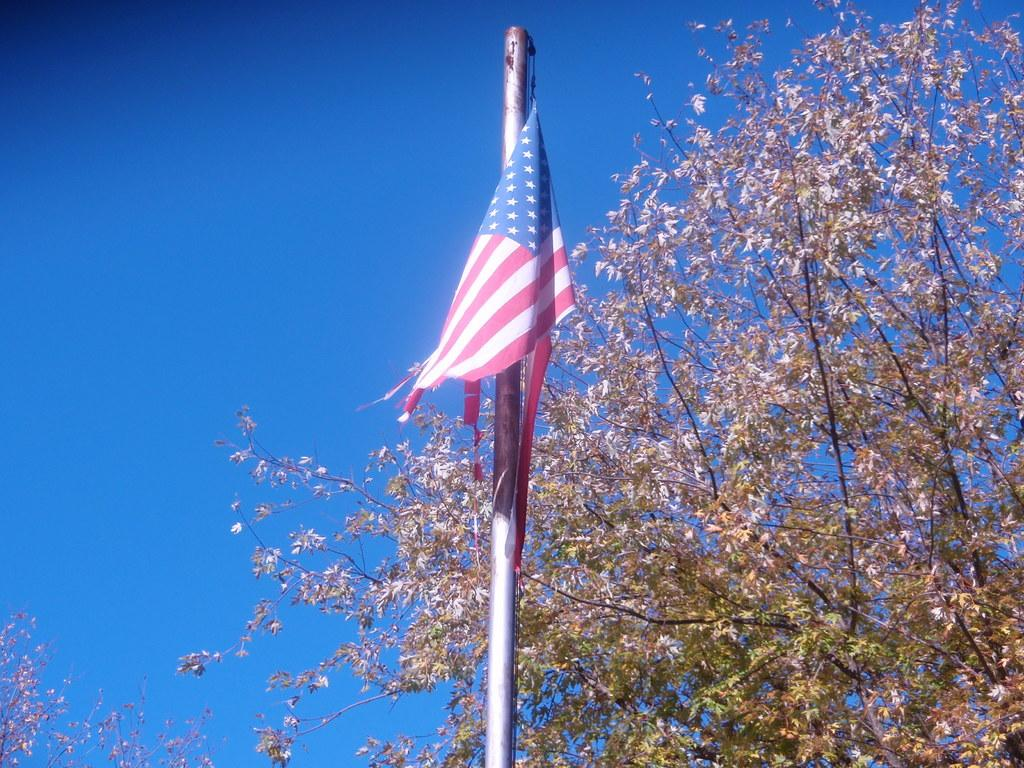What is the main object in the image? There is a flag of a country in the image. What is the flag attached to? There is a pole in the image, and the flag is attached to it. What other natural element is present in the image? There is a tree in the image. What can be seen in the background of the image? The sky is visible in the image. What degree of difficulty is the tree in the image rated? The image does not provide any information about the difficulty level of the tree. Trees do not have degrees of difficulty, as they are natural elements and not challenges or tasks. 